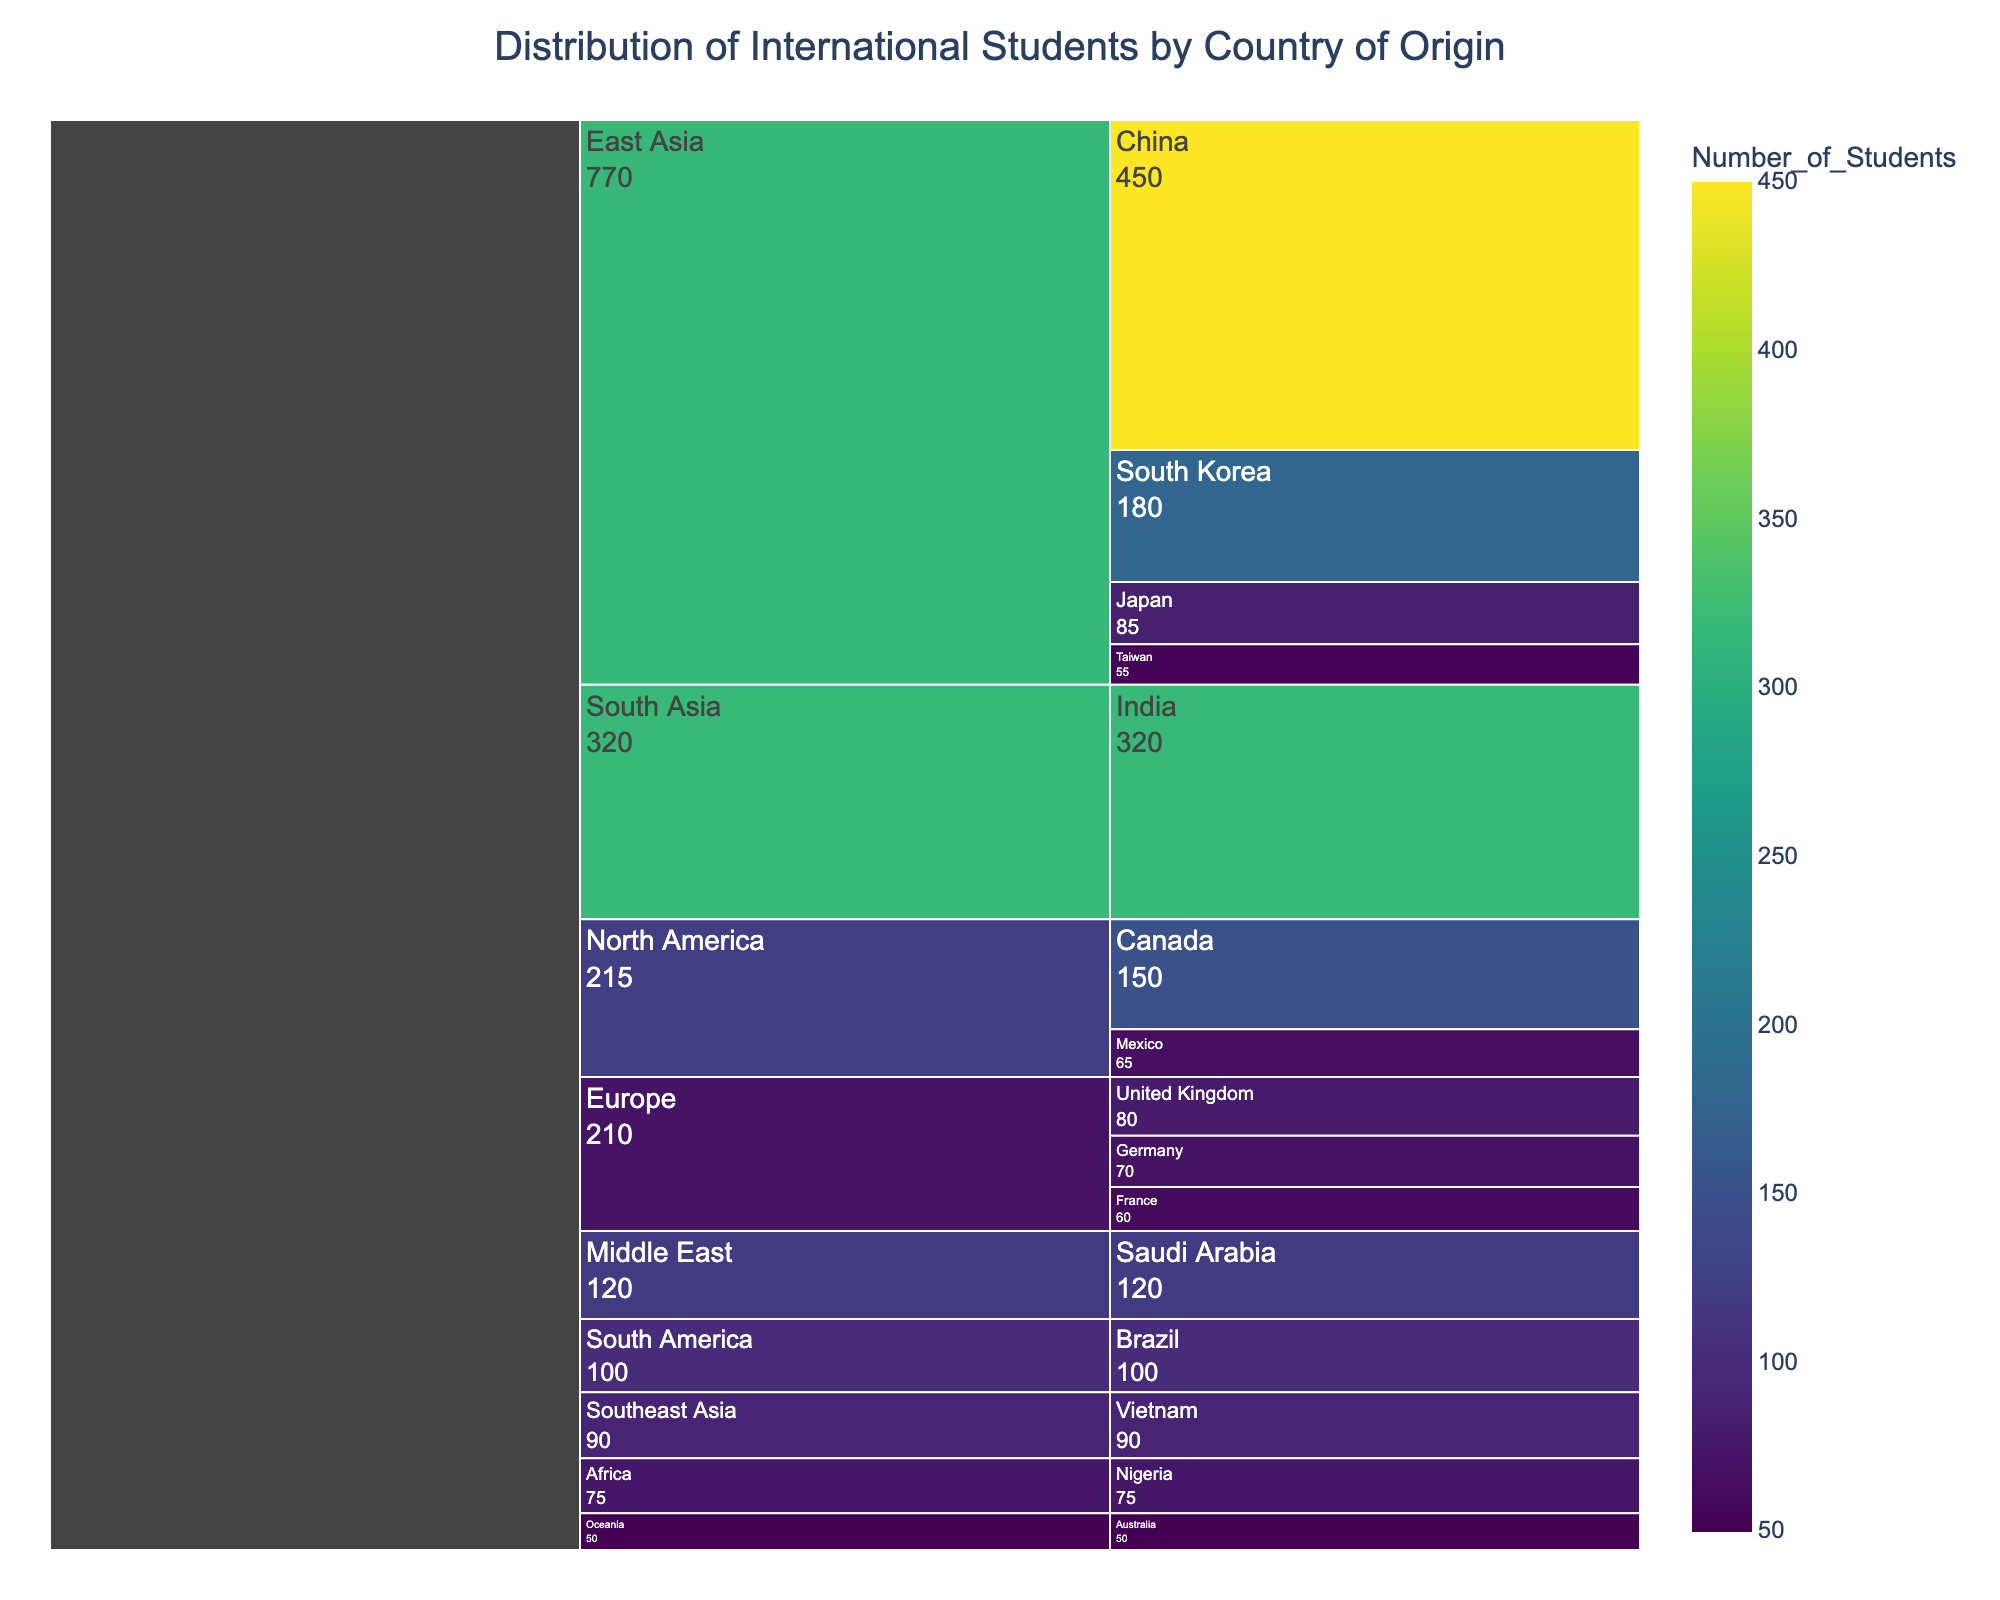What's the title of the figure? The title is usually displayed at the top center of the figure. In this case, the title is defined as 'Distribution of International Students by Country of Origin'.
Answer: Distribution of International Students by Country of Origin Which region has the highest number of international students? By glancing at the various regions and summing their respective values, East Asia clearly stands out with four countries contributing a substantial number of students (China, South Korea, Japan, and Taiwan).
Answer: East Asia How many students come from Europe in total? Adding the numbers from the countries in Europe: United Kingdom (80), Germany (70), and France (60). Summing these gives 80 + 70 + 60 = 210 students.
Answer: 210 Which country from South Asia has students at the college? By checking the region South Asia in the icicle chart, we can see that only India is listed under this region.
Answer: India What is the difference in the number of students from China and South Korea? The number of students from China is 450 and from South Korea is 180. The difference is calculated as 450 - 180 = 270.
Answer: 270 How many more students are there from East Asia compared to North America? Total students from East Asia are (China 450 + South Korea 180 + Japan 85 + Taiwan 55 = 770). North America has (Canada 150 + Mexico 65 = 215). The difference is 770 - 215 = 555.
Answer: 555 Which country in the Middle East contributes international students, and how many? By looking in the Middle East section of the icicle chart, Saudi Arabia is present and contributes 120 students.
Answer: Saudi Arabia, 120 Are there more students from Nigeria or Vietnam? By comparing the numbers, Nigeria has 75 students, whereas Vietnam has 90 students. Therefore, Vietnam has more students.
Answer: Vietnam What is the total number of international students from Oceania and Southeast Asia combined? Oceania (Australia 50) plus Southeast Asia (Vietnam 90) gives 50 + 90 = 140 students.
Answer: 140 Which region has the least representation by a single country, and what is that country? Oceania with only Australia contributing 50 students has the least representation by a single country compared to other regions with multiple countries.
Answer: Oceania, Australia 